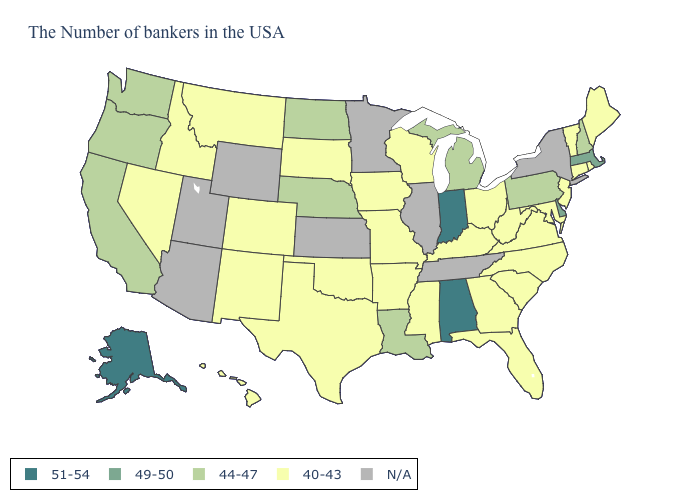What is the value of Michigan?
Answer briefly. 44-47. What is the lowest value in the USA?
Answer briefly. 40-43. What is the value of Rhode Island?
Keep it brief. 40-43. What is the value of Nebraska?
Short answer required. 44-47. What is the value of Delaware?
Concise answer only. 49-50. Name the states that have a value in the range 44-47?
Keep it brief. New Hampshire, Pennsylvania, Michigan, Louisiana, Nebraska, North Dakota, California, Washington, Oregon. What is the value of New York?
Keep it brief. N/A. What is the value of Idaho?
Be succinct. 40-43. Name the states that have a value in the range 51-54?
Answer briefly. Indiana, Alabama, Alaska. Which states have the lowest value in the USA?
Answer briefly. Maine, Rhode Island, Vermont, Connecticut, New Jersey, Maryland, Virginia, North Carolina, South Carolina, West Virginia, Ohio, Florida, Georgia, Kentucky, Wisconsin, Mississippi, Missouri, Arkansas, Iowa, Oklahoma, Texas, South Dakota, Colorado, New Mexico, Montana, Idaho, Nevada, Hawaii. Among the states that border New Hampshire , does Maine have the lowest value?
Quick response, please. Yes. What is the highest value in the MidWest ?
Concise answer only. 51-54. Name the states that have a value in the range 44-47?
Write a very short answer. New Hampshire, Pennsylvania, Michigan, Louisiana, Nebraska, North Dakota, California, Washington, Oregon. What is the value of Illinois?
Keep it brief. N/A. 